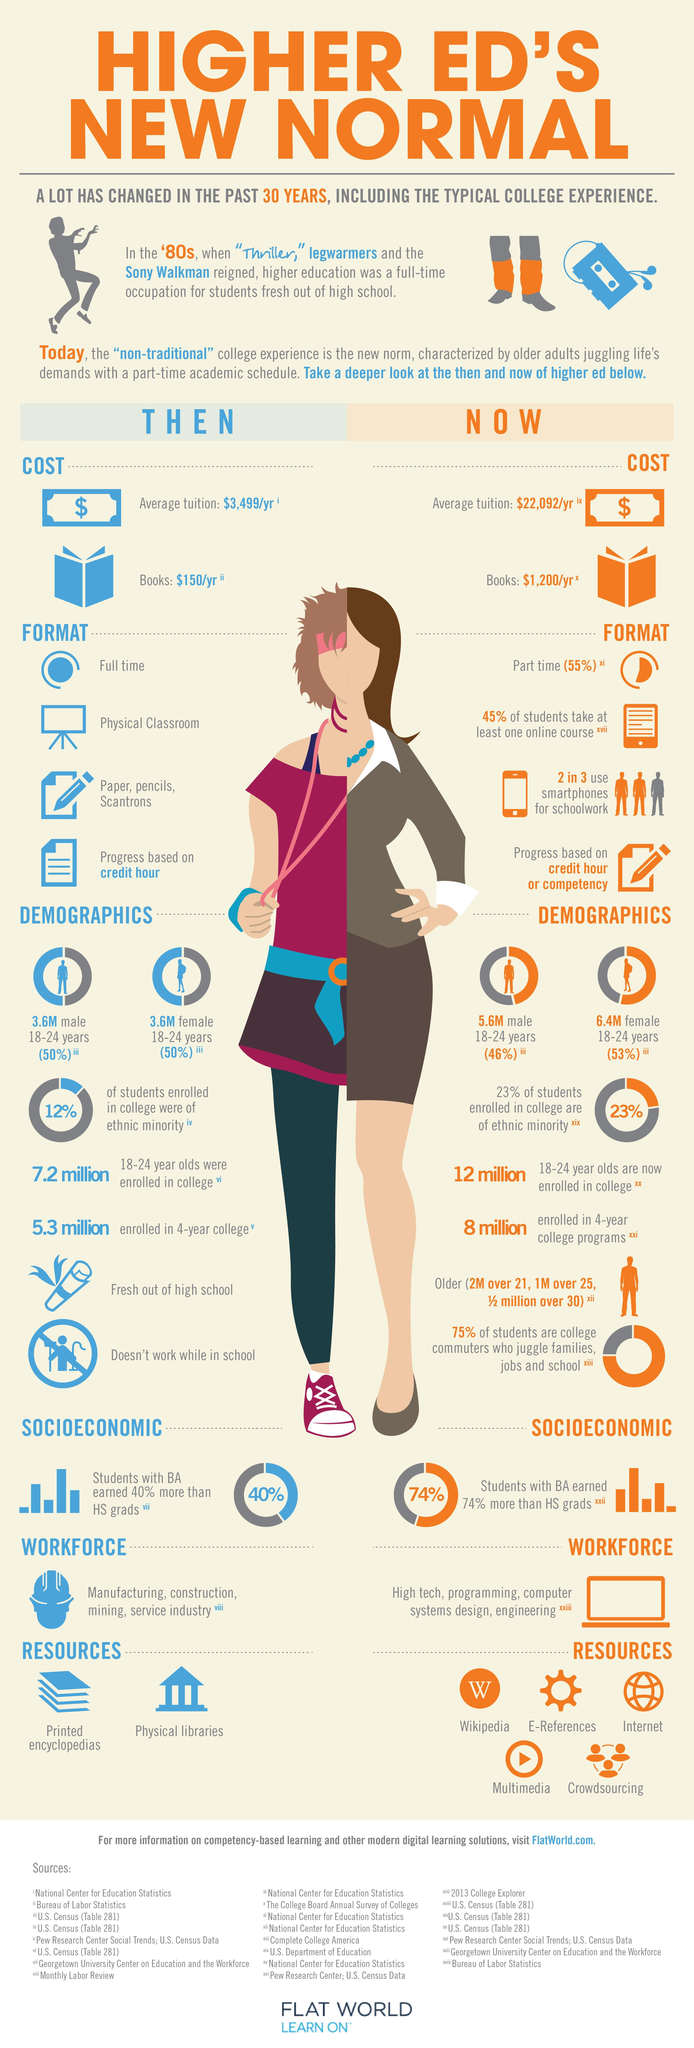How many resources for college education are being used now?
Answer the question with a short phrase. 5 What was the increase in the cost of tuition fees since 30 years ago and now? $18,593 Which resources were used 30 years back for college education? Printed encyclopedias, Physical libraries What is the increase in the cost of books from 30 years ago and now? $1050 What has been the increase in female students seeking education then and now? 2.8 M What is the percentage difference between male and female students taking up non-traditional college experience? 7% 